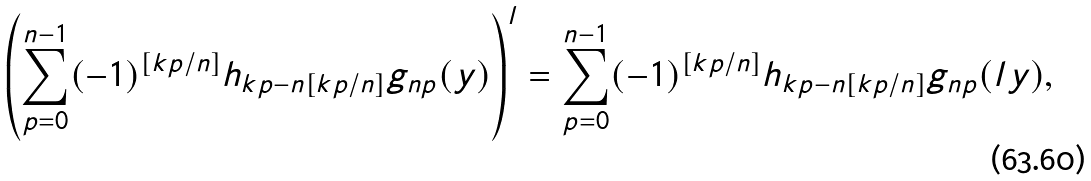<formula> <loc_0><loc_0><loc_500><loc_500>\left ( \sum _ { p = 0 } ^ { n - 1 } ( - 1 ) ^ { [ k p / n ] } h _ { k p - n [ k p / n ] } g _ { n p } ( y ) \right ) ^ { l } = \sum _ { p = 0 } ^ { n - 1 } ( - 1 ) ^ { [ k p / n ] } h _ { k p - n [ k p / n ] } g _ { n p } ( l y ) ,</formula> 